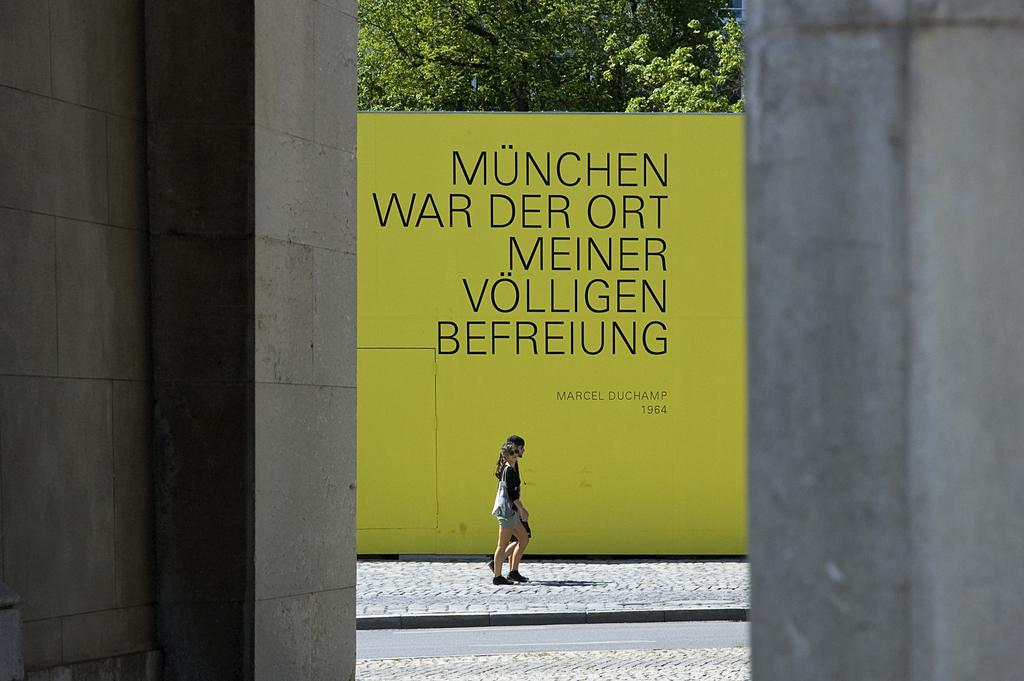What is the lady in the image doing? The lady is walking in the image. On what surface is the lady walking? The lady is walking on a pavement. What can be seen in the background of the image? There is a display board in the image, and trees are present behind the display board. What type of advice is being exchanged between the lady and the trees in the image? There is no exchange of advice between the lady and the trees in the image, as trees do not communicate in that manner. 